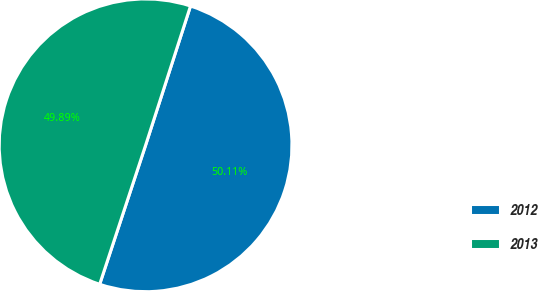Convert chart. <chart><loc_0><loc_0><loc_500><loc_500><pie_chart><fcel>2012<fcel>2013<nl><fcel>50.11%<fcel>49.89%<nl></chart> 